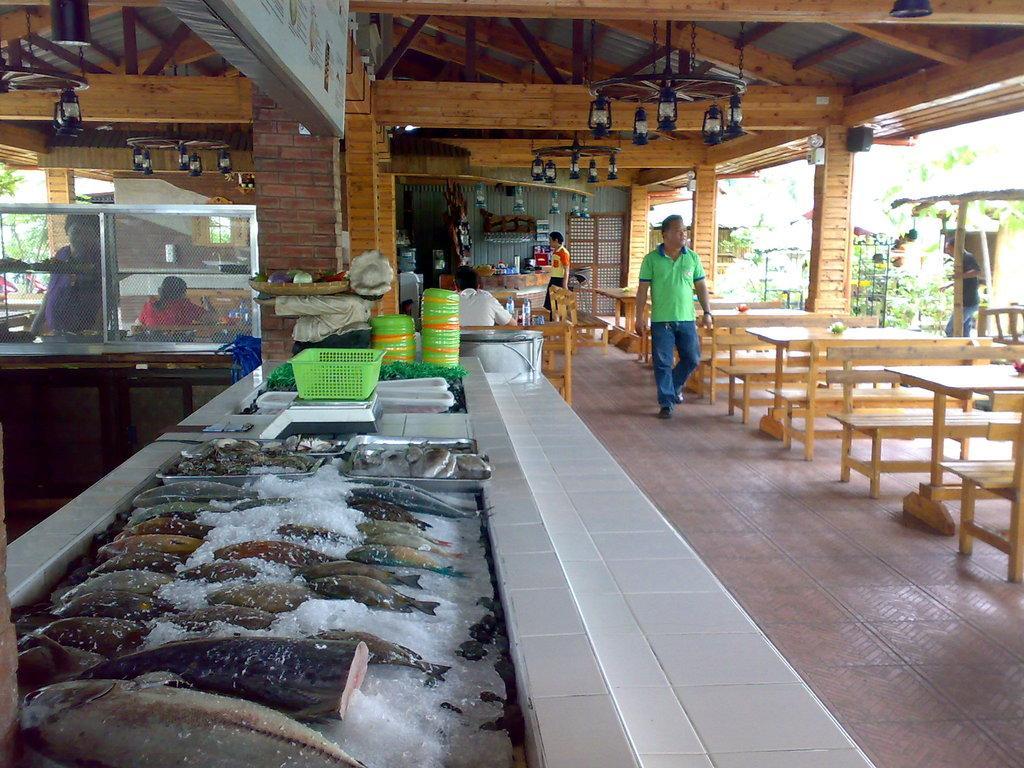How would you summarize this image in a sentence or two? In the image we can see there is a tray in which there are fishes kept and the man is standing on floor and the people who are sitting over here and there are plates and a basket and benches are kept on the floor. 